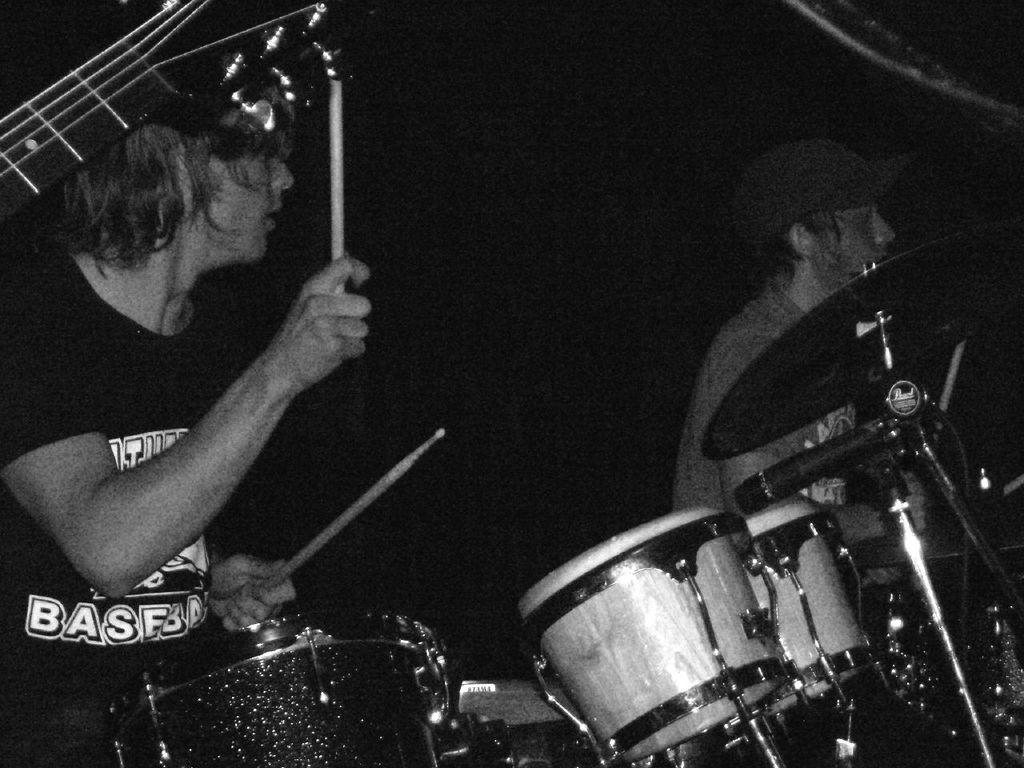What are the two men in the image doing? The two men in the image are playing musical instruments. What specific instrument is one of the men playing? One of the men is playing drums in the image. Can you see any windows or scales in the image? There is no mention of windows or scales in the image; it features two men playing musical instruments. Is there a market visible in the image? There is no mention of a market in the image; it only shows two men playing musical instruments. 